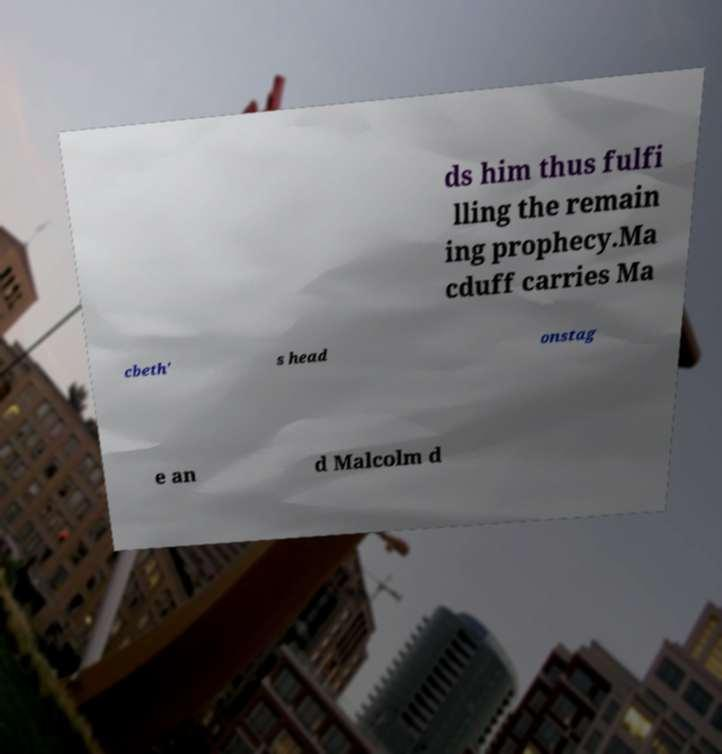Could you assist in decoding the text presented in this image and type it out clearly? ds him thus fulfi lling the remain ing prophecy.Ma cduff carries Ma cbeth' s head onstag e an d Malcolm d 